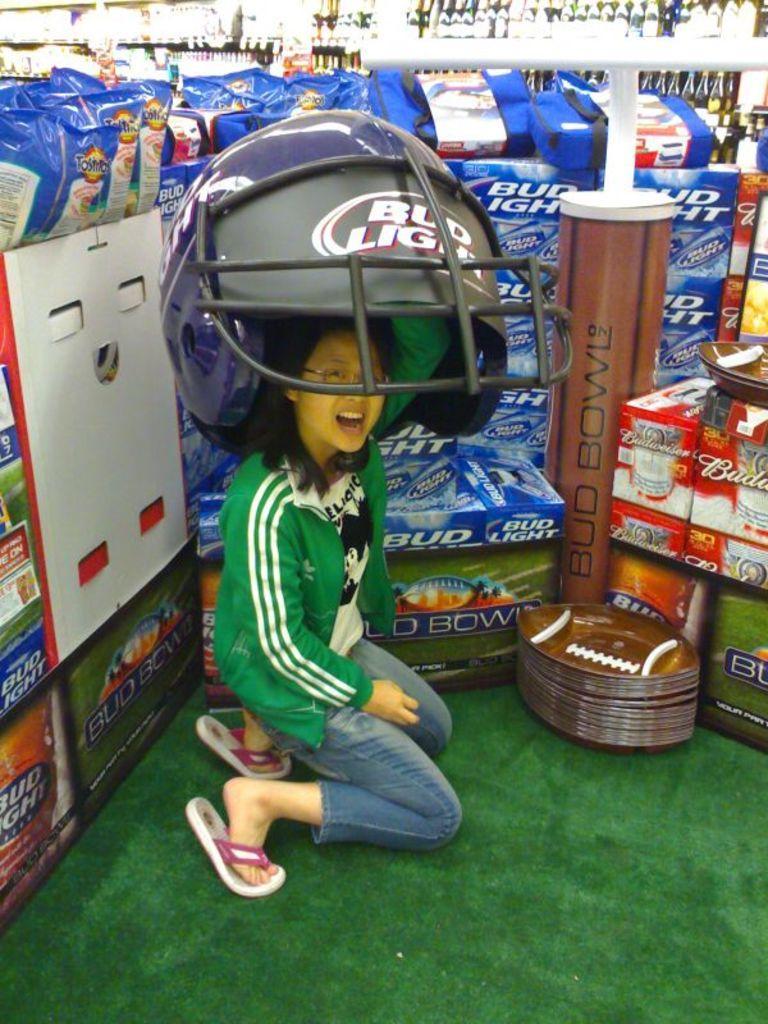Could you give a brief overview of what you see in this image? In this image we can see this person wearing green color sweater is sitting on the ground and wearing a big helmet on her head. Here we can see the plates, packets, and boxes are kept on the shelf. In the background, we can see bottles kept on the shelf. 